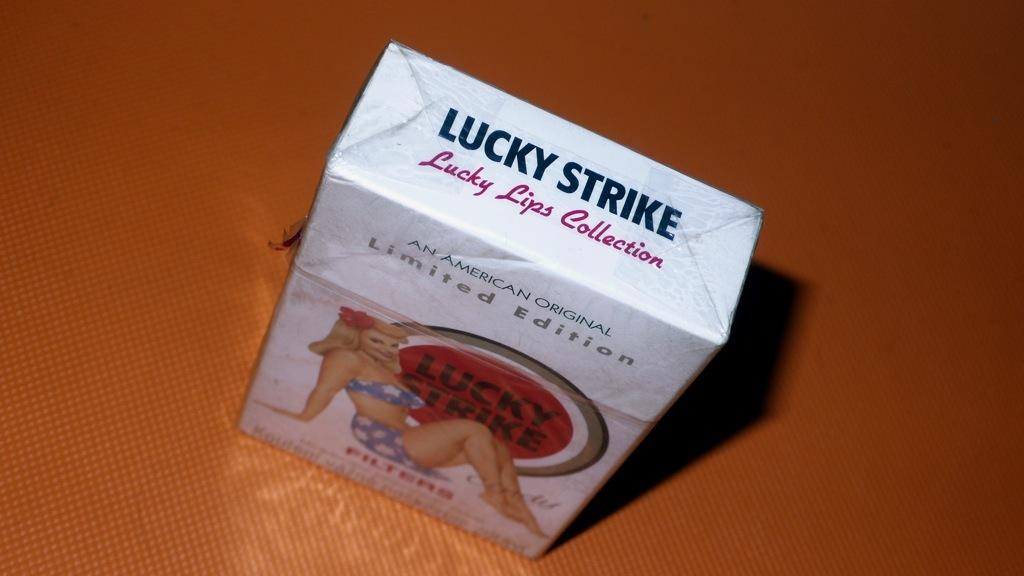What object can be seen in the image? There is a box in the image. Where is the box located? The box is on a table. How many cars are parked inside the box in the image? There are no cars present in the image, as it only features a box on a table. 